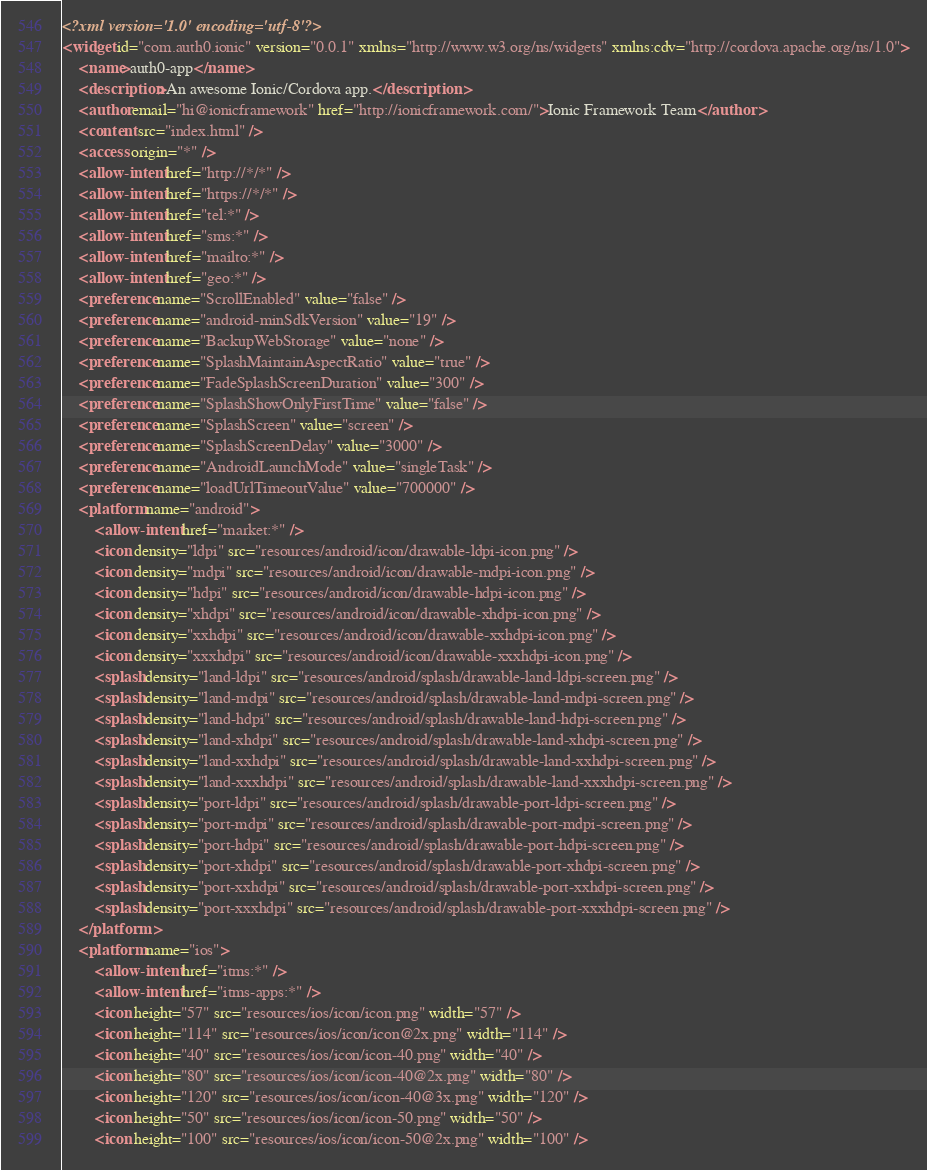<code> <loc_0><loc_0><loc_500><loc_500><_XML_><?xml version='1.0' encoding='utf-8'?>
<widget id="com.auth0.ionic" version="0.0.1" xmlns="http://www.w3.org/ns/widgets" xmlns:cdv="http://cordova.apache.org/ns/1.0">
    <name>auth0-app</name>
    <description>An awesome Ionic/Cordova app.</description>
    <author email="hi@ionicframework" href="http://ionicframework.com/">Ionic Framework Team</author>
    <content src="index.html" />
    <access origin="*" />
    <allow-intent href="http://*/*" />
    <allow-intent href="https://*/*" />
    <allow-intent href="tel:*" />
    <allow-intent href="sms:*" />
    <allow-intent href="mailto:*" />
    <allow-intent href="geo:*" />
    <preference name="ScrollEnabled" value="false" />
    <preference name="android-minSdkVersion" value="19" />
    <preference name="BackupWebStorage" value="none" />
    <preference name="SplashMaintainAspectRatio" value="true" />
    <preference name="FadeSplashScreenDuration" value="300" />
    <preference name="SplashShowOnlyFirstTime" value="false" />
    <preference name="SplashScreen" value="screen" />
    <preference name="SplashScreenDelay" value="3000" />
    <preference name="AndroidLaunchMode" value="singleTask" />
    <preference name="loadUrlTimeoutValue" value="700000" />
    <platform name="android">
        <allow-intent href="market:*" />
        <icon density="ldpi" src="resources/android/icon/drawable-ldpi-icon.png" />
        <icon density="mdpi" src="resources/android/icon/drawable-mdpi-icon.png" />
        <icon density="hdpi" src="resources/android/icon/drawable-hdpi-icon.png" />
        <icon density="xhdpi" src="resources/android/icon/drawable-xhdpi-icon.png" />
        <icon density="xxhdpi" src="resources/android/icon/drawable-xxhdpi-icon.png" />
        <icon density="xxxhdpi" src="resources/android/icon/drawable-xxxhdpi-icon.png" />
        <splash density="land-ldpi" src="resources/android/splash/drawable-land-ldpi-screen.png" />
        <splash density="land-mdpi" src="resources/android/splash/drawable-land-mdpi-screen.png" />
        <splash density="land-hdpi" src="resources/android/splash/drawable-land-hdpi-screen.png" />
        <splash density="land-xhdpi" src="resources/android/splash/drawable-land-xhdpi-screen.png" />
        <splash density="land-xxhdpi" src="resources/android/splash/drawable-land-xxhdpi-screen.png" />
        <splash density="land-xxxhdpi" src="resources/android/splash/drawable-land-xxxhdpi-screen.png" />
        <splash density="port-ldpi" src="resources/android/splash/drawable-port-ldpi-screen.png" />
        <splash density="port-mdpi" src="resources/android/splash/drawable-port-mdpi-screen.png" />
        <splash density="port-hdpi" src="resources/android/splash/drawable-port-hdpi-screen.png" />
        <splash density="port-xhdpi" src="resources/android/splash/drawable-port-xhdpi-screen.png" />
        <splash density="port-xxhdpi" src="resources/android/splash/drawable-port-xxhdpi-screen.png" />
        <splash density="port-xxxhdpi" src="resources/android/splash/drawable-port-xxxhdpi-screen.png" />
    </platform>
    <platform name="ios">
        <allow-intent href="itms:*" />
        <allow-intent href="itms-apps:*" />
        <icon height="57" src="resources/ios/icon/icon.png" width="57" />
        <icon height="114" src="resources/ios/icon/icon@2x.png" width="114" />
        <icon height="40" src="resources/ios/icon/icon-40.png" width="40" />
        <icon height="80" src="resources/ios/icon/icon-40@2x.png" width="80" />
        <icon height="120" src="resources/ios/icon/icon-40@3x.png" width="120" />
        <icon height="50" src="resources/ios/icon/icon-50.png" width="50" />
        <icon height="100" src="resources/ios/icon/icon-50@2x.png" width="100" /></code> 